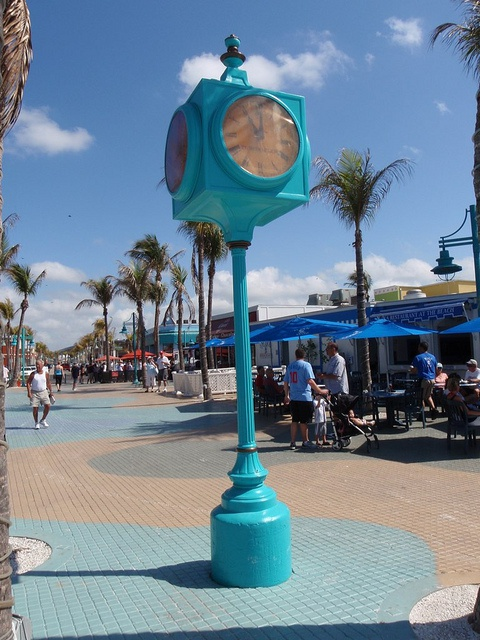Describe the objects in this image and their specific colors. I can see clock in black, gray, tan, and teal tones, clock in black, blue, navy, and purple tones, people in black, darkblue, navy, and maroon tones, people in black, gray, darkgray, and lavender tones, and umbrella in black, navy, blue, gray, and darkblue tones in this image. 